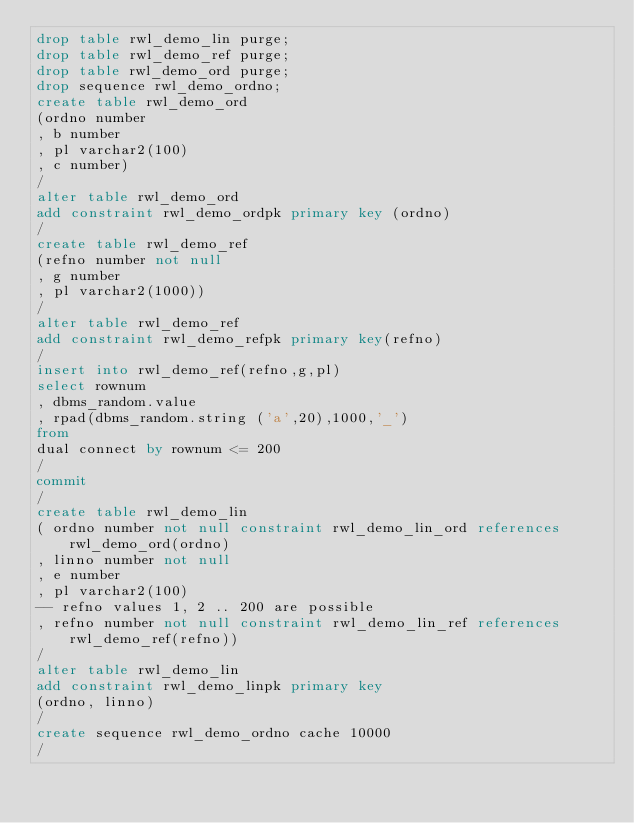<code> <loc_0><loc_0><loc_500><loc_500><_SQL_>drop table rwl_demo_lin purge;
drop table rwl_demo_ref purge;
drop table rwl_demo_ord purge;
drop sequence rwl_demo_ordno;
create table rwl_demo_ord 
(ordno number
, b number
, pl varchar2(100)
, c number)
/
alter table rwl_demo_ord 
add constraint rwl_demo_ordpk primary key (ordno)
/
create table rwl_demo_ref 
(refno number not null
, g number
, pl varchar2(1000))
/
alter table rwl_demo_ref
add constraint rwl_demo_refpk primary key(refno)
/
insert into rwl_demo_ref(refno,g,pl)
select rownum
, dbms_random.value
, rpad(dbms_random.string ('a',20),1000,'_')
from 
dual connect by rownum <= 200
/
commit
/
create table rwl_demo_lin 
( ordno number not null constraint rwl_demo_lin_ord references rwl_demo_ord(ordno)
, linno number not null
, e number
, pl varchar2(100)
-- refno values 1, 2 .. 200 are possible
, refno number not null constraint rwl_demo_lin_ref references rwl_demo_ref(refno))
/
alter table rwl_demo_lin 
add constraint rwl_demo_linpk primary key 
(ordno, linno)
/
create sequence rwl_demo_ordno cache 10000
/
</code> 